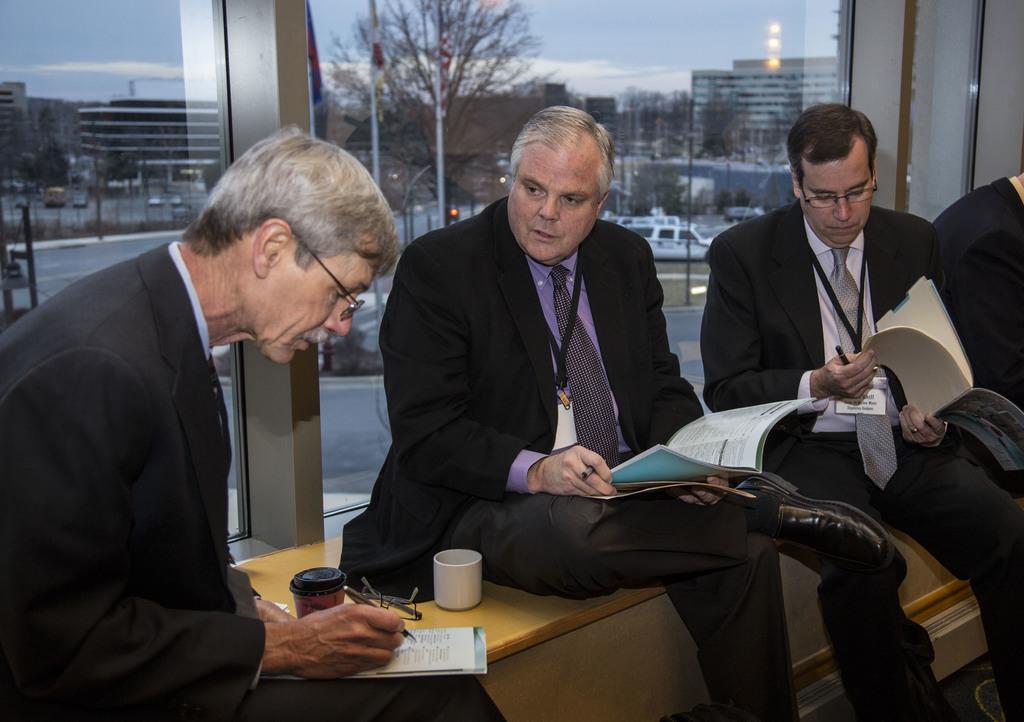Describe this image in one or two sentences. In this image, we can see three persons wearing clothes and sitting in front of the window. These three persons are holding books with their hands. There is a tree and building at the top of the image. 